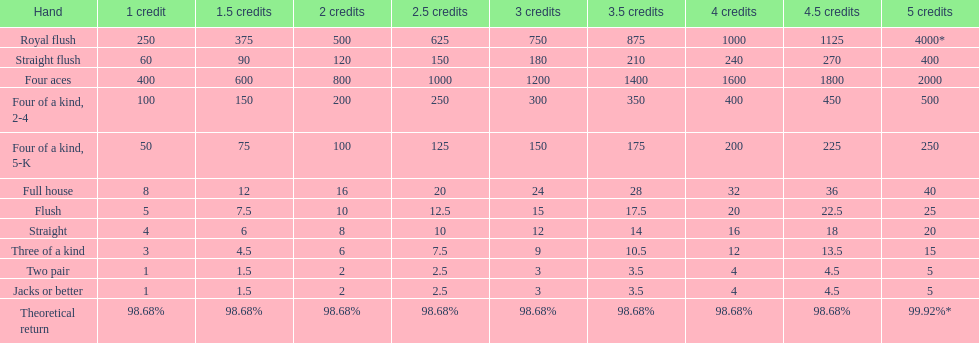Parse the full table. {'header': ['Hand', '1 credit', '1.5 credits', '2 credits', '2.5 credits', '3 credits', '3.5 credits', '4 credits', '4.5 credits', '5 credits'], 'rows': [['Royal flush', '250', '375', '500', '625', '750', '875', '1000', '1125', '4000*'], ['Straight flush', '60', '90', '120', '150', '180', '210', '240', '270', '400'], ['Four aces', '400', '600', '800', '1000', '1200', '1400', '1600', '1800', '2000'], ['Four of a kind, 2-4', '100', '150', '200', '250', '300', '350', '400', '450', '500'], ['Four of a kind, 5-K', '50', '75', '100', '125', '150', '175', '200', '225', '250'], ['Full house', '8', '12', '16', '20', '24', '28', '32', '36', '40'], ['Flush', '5', '7.5', '10', '12.5', '15', '17.5', '20', '22.5', '25'], ['Straight', '4', '6', '8', '10', '12', '14', '16', '18', '20'], ['Three of a kind', '3', '4.5', '6', '7.5', '9', '10.5', '12', '13.5', '15'], ['Two pair', '1', '1.5', '2', '2.5', '3', '3.5', '4', '4.5', '5'], ['Jacks or better', '1', '1.5', '2', '2.5', '3', '3.5', '4', '4.5', '5'], ['Theoretical return', '98.68%', '98.68%', '98.68%', '98.68%', '98.68%', '98.68%', '98.68%', '98.68%', '99.92%*']]} Which hand is the top hand in the card game super aces? Royal flush. 